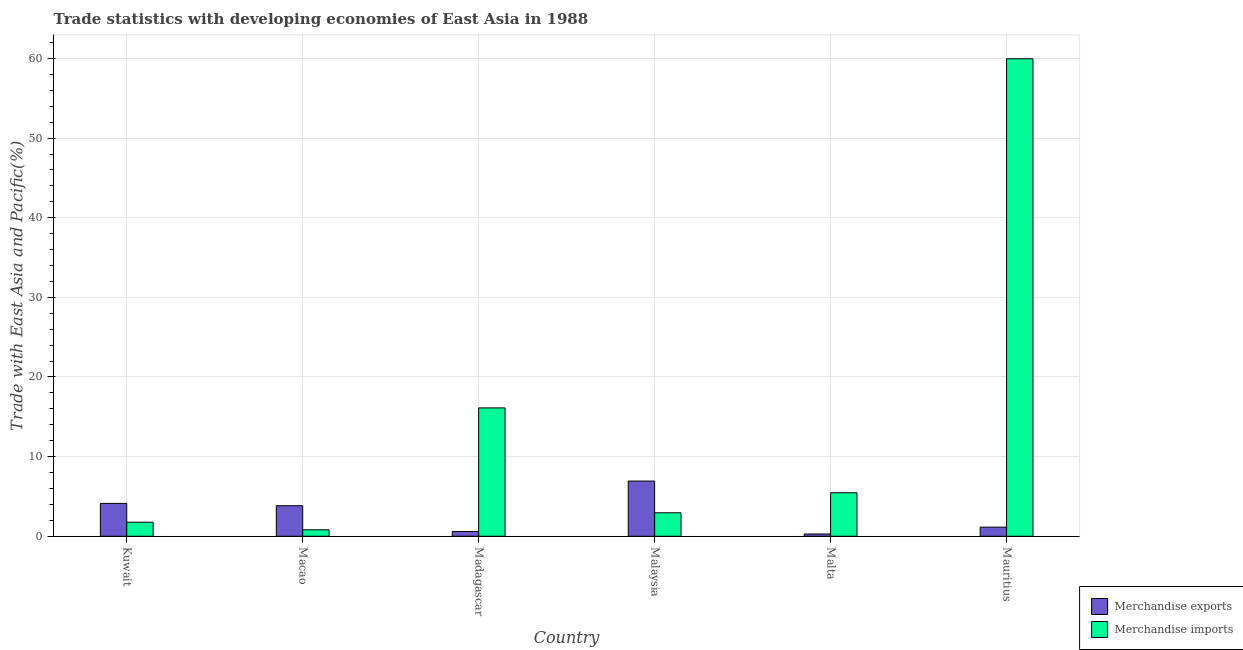Are the number of bars per tick equal to the number of legend labels?
Ensure brevity in your answer.  Yes. How many bars are there on the 5th tick from the left?
Give a very brief answer. 2. How many bars are there on the 6th tick from the right?
Keep it short and to the point. 2. What is the label of the 2nd group of bars from the left?
Ensure brevity in your answer.  Macao. In how many cases, is the number of bars for a given country not equal to the number of legend labels?
Your answer should be compact. 0. What is the merchandise imports in Madagascar?
Your answer should be very brief. 16.12. Across all countries, what is the maximum merchandise imports?
Your response must be concise. 59.97. Across all countries, what is the minimum merchandise imports?
Offer a terse response. 0.81. In which country was the merchandise exports maximum?
Offer a very short reply. Malaysia. In which country was the merchandise imports minimum?
Keep it short and to the point. Macao. What is the total merchandise imports in the graph?
Give a very brief answer. 87.07. What is the difference between the merchandise imports in Kuwait and that in Mauritius?
Your answer should be compact. -58.2. What is the difference between the merchandise imports in Malaysia and the merchandise exports in Malta?
Your answer should be very brief. 2.66. What is the average merchandise exports per country?
Make the answer very short. 2.82. What is the difference between the merchandise exports and merchandise imports in Kuwait?
Ensure brevity in your answer.  2.36. In how many countries, is the merchandise imports greater than 38 %?
Make the answer very short. 1. What is the ratio of the merchandise exports in Kuwait to that in Madagascar?
Provide a succinct answer. 6.95. What is the difference between the highest and the second highest merchandise exports?
Offer a terse response. 2.8. What is the difference between the highest and the lowest merchandise imports?
Provide a succinct answer. 59.16. In how many countries, is the merchandise exports greater than the average merchandise exports taken over all countries?
Keep it short and to the point. 3. What does the 1st bar from the left in Kuwait represents?
Your answer should be compact. Merchandise exports. Are all the bars in the graph horizontal?
Provide a succinct answer. No. How many countries are there in the graph?
Keep it short and to the point. 6. Does the graph contain any zero values?
Offer a terse response. No. What is the title of the graph?
Make the answer very short. Trade statistics with developing economies of East Asia in 1988. Does "Not attending school" appear as one of the legend labels in the graph?
Your response must be concise. No. What is the label or title of the X-axis?
Offer a terse response. Country. What is the label or title of the Y-axis?
Your answer should be very brief. Trade with East Asia and Pacific(%). What is the Trade with East Asia and Pacific(%) in Merchandise exports in Kuwait?
Make the answer very short. 4.13. What is the Trade with East Asia and Pacific(%) in Merchandise imports in Kuwait?
Keep it short and to the point. 1.76. What is the Trade with East Asia and Pacific(%) in Merchandise exports in Macao?
Offer a terse response. 3.84. What is the Trade with East Asia and Pacific(%) of Merchandise imports in Macao?
Offer a terse response. 0.81. What is the Trade with East Asia and Pacific(%) of Merchandise exports in Madagascar?
Keep it short and to the point. 0.59. What is the Trade with East Asia and Pacific(%) of Merchandise imports in Madagascar?
Your answer should be very brief. 16.12. What is the Trade with East Asia and Pacific(%) of Merchandise exports in Malaysia?
Offer a terse response. 6.93. What is the Trade with East Asia and Pacific(%) of Merchandise imports in Malaysia?
Your response must be concise. 2.95. What is the Trade with East Asia and Pacific(%) in Merchandise exports in Malta?
Offer a very short reply. 0.28. What is the Trade with East Asia and Pacific(%) in Merchandise imports in Malta?
Offer a very short reply. 5.46. What is the Trade with East Asia and Pacific(%) of Merchandise exports in Mauritius?
Keep it short and to the point. 1.15. What is the Trade with East Asia and Pacific(%) in Merchandise imports in Mauritius?
Give a very brief answer. 59.97. Across all countries, what is the maximum Trade with East Asia and Pacific(%) in Merchandise exports?
Provide a succinct answer. 6.93. Across all countries, what is the maximum Trade with East Asia and Pacific(%) of Merchandise imports?
Your answer should be very brief. 59.97. Across all countries, what is the minimum Trade with East Asia and Pacific(%) of Merchandise exports?
Offer a very short reply. 0.28. Across all countries, what is the minimum Trade with East Asia and Pacific(%) in Merchandise imports?
Provide a short and direct response. 0.81. What is the total Trade with East Asia and Pacific(%) of Merchandise exports in the graph?
Offer a very short reply. 16.91. What is the total Trade with East Asia and Pacific(%) in Merchandise imports in the graph?
Your response must be concise. 87.07. What is the difference between the Trade with East Asia and Pacific(%) in Merchandise exports in Kuwait and that in Macao?
Offer a terse response. 0.29. What is the difference between the Trade with East Asia and Pacific(%) in Merchandise imports in Kuwait and that in Macao?
Offer a very short reply. 0.95. What is the difference between the Trade with East Asia and Pacific(%) of Merchandise exports in Kuwait and that in Madagascar?
Offer a terse response. 3.53. What is the difference between the Trade with East Asia and Pacific(%) in Merchandise imports in Kuwait and that in Madagascar?
Provide a short and direct response. -14.36. What is the difference between the Trade with East Asia and Pacific(%) of Merchandise exports in Kuwait and that in Malaysia?
Offer a very short reply. -2.8. What is the difference between the Trade with East Asia and Pacific(%) of Merchandise imports in Kuwait and that in Malaysia?
Ensure brevity in your answer.  -1.18. What is the difference between the Trade with East Asia and Pacific(%) in Merchandise exports in Kuwait and that in Malta?
Your answer should be compact. 3.84. What is the difference between the Trade with East Asia and Pacific(%) in Merchandise imports in Kuwait and that in Malta?
Your answer should be compact. -3.7. What is the difference between the Trade with East Asia and Pacific(%) of Merchandise exports in Kuwait and that in Mauritius?
Your response must be concise. 2.98. What is the difference between the Trade with East Asia and Pacific(%) in Merchandise imports in Kuwait and that in Mauritius?
Ensure brevity in your answer.  -58.2. What is the difference between the Trade with East Asia and Pacific(%) of Merchandise exports in Macao and that in Madagascar?
Offer a very short reply. 3.24. What is the difference between the Trade with East Asia and Pacific(%) in Merchandise imports in Macao and that in Madagascar?
Your answer should be compact. -15.31. What is the difference between the Trade with East Asia and Pacific(%) in Merchandise exports in Macao and that in Malaysia?
Offer a terse response. -3.09. What is the difference between the Trade with East Asia and Pacific(%) of Merchandise imports in Macao and that in Malaysia?
Your response must be concise. -2.14. What is the difference between the Trade with East Asia and Pacific(%) in Merchandise exports in Macao and that in Malta?
Offer a terse response. 3.55. What is the difference between the Trade with East Asia and Pacific(%) in Merchandise imports in Macao and that in Malta?
Your answer should be compact. -4.65. What is the difference between the Trade with East Asia and Pacific(%) of Merchandise exports in Macao and that in Mauritius?
Provide a succinct answer. 2.69. What is the difference between the Trade with East Asia and Pacific(%) in Merchandise imports in Macao and that in Mauritius?
Provide a succinct answer. -59.16. What is the difference between the Trade with East Asia and Pacific(%) in Merchandise exports in Madagascar and that in Malaysia?
Give a very brief answer. -6.34. What is the difference between the Trade with East Asia and Pacific(%) in Merchandise imports in Madagascar and that in Malaysia?
Make the answer very short. 13.17. What is the difference between the Trade with East Asia and Pacific(%) of Merchandise exports in Madagascar and that in Malta?
Ensure brevity in your answer.  0.31. What is the difference between the Trade with East Asia and Pacific(%) in Merchandise imports in Madagascar and that in Malta?
Provide a short and direct response. 10.66. What is the difference between the Trade with East Asia and Pacific(%) of Merchandise exports in Madagascar and that in Mauritius?
Provide a short and direct response. -0.55. What is the difference between the Trade with East Asia and Pacific(%) in Merchandise imports in Madagascar and that in Mauritius?
Provide a short and direct response. -43.85. What is the difference between the Trade with East Asia and Pacific(%) in Merchandise exports in Malaysia and that in Malta?
Provide a short and direct response. 6.65. What is the difference between the Trade with East Asia and Pacific(%) in Merchandise imports in Malaysia and that in Malta?
Provide a short and direct response. -2.52. What is the difference between the Trade with East Asia and Pacific(%) in Merchandise exports in Malaysia and that in Mauritius?
Offer a very short reply. 5.78. What is the difference between the Trade with East Asia and Pacific(%) of Merchandise imports in Malaysia and that in Mauritius?
Keep it short and to the point. -57.02. What is the difference between the Trade with East Asia and Pacific(%) in Merchandise exports in Malta and that in Mauritius?
Your answer should be very brief. -0.86. What is the difference between the Trade with East Asia and Pacific(%) of Merchandise imports in Malta and that in Mauritius?
Your response must be concise. -54.5. What is the difference between the Trade with East Asia and Pacific(%) of Merchandise exports in Kuwait and the Trade with East Asia and Pacific(%) of Merchandise imports in Macao?
Your response must be concise. 3.32. What is the difference between the Trade with East Asia and Pacific(%) in Merchandise exports in Kuwait and the Trade with East Asia and Pacific(%) in Merchandise imports in Madagascar?
Provide a short and direct response. -11.99. What is the difference between the Trade with East Asia and Pacific(%) of Merchandise exports in Kuwait and the Trade with East Asia and Pacific(%) of Merchandise imports in Malaysia?
Your response must be concise. 1.18. What is the difference between the Trade with East Asia and Pacific(%) of Merchandise exports in Kuwait and the Trade with East Asia and Pacific(%) of Merchandise imports in Malta?
Your response must be concise. -1.34. What is the difference between the Trade with East Asia and Pacific(%) in Merchandise exports in Kuwait and the Trade with East Asia and Pacific(%) in Merchandise imports in Mauritius?
Offer a very short reply. -55.84. What is the difference between the Trade with East Asia and Pacific(%) in Merchandise exports in Macao and the Trade with East Asia and Pacific(%) in Merchandise imports in Madagascar?
Offer a terse response. -12.28. What is the difference between the Trade with East Asia and Pacific(%) in Merchandise exports in Macao and the Trade with East Asia and Pacific(%) in Merchandise imports in Malaysia?
Ensure brevity in your answer.  0.89. What is the difference between the Trade with East Asia and Pacific(%) of Merchandise exports in Macao and the Trade with East Asia and Pacific(%) of Merchandise imports in Malta?
Your answer should be compact. -1.63. What is the difference between the Trade with East Asia and Pacific(%) in Merchandise exports in Macao and the Trade with East Asia and Pacific(%) in Merchandise imports in Mauritius?
Provide a succinct answer. -56.13. What is the difference between the Trade with East Asia and Pacific(%) of Merchandise exports in Madagascar and the Trade with East Asia and Pacific(%) of Merchandise imports in Malaysia?
Your answer should be very brief. -2.36. What is the difference between the Trade with East Asia and Pacific(%) of Merchandise exports in Madagascar and the Trade with East Asia and Pacific(%) of Merchandise imports in Malta?
Offer a very short reply. -4.87. What is the difference between the Trade with East Asia and Pacific(%) in Merchandise exports in Madagascar and the Trade with East Asia and Pacific(%) in Merchandise imports in Mauritius?
Keep it short and to the point. -59.37. What is the difference between the Trade with East Asia and Pacific(%) of Merchandise exports in Malaysia and the Trade with East Asia and Pacific(%) of Merchandise imports in Malta?
Your response must be concise. 1.47. What is the difference between the Trade with East Asia and Pacific(%) of Merchandise exports in Malaysia and the Trade with East Asia and Pacific(%) of Merchandise imports in Mauritius?
Your answer should be very brief. -53.04. What is the difference between the Trade with East Asia and Pacific(%) in Merchandise exports in Malta and the Trade with East Asia and Pacific(%) in Merchandise imports in Mauritius?
Give a very brief answer. -59.68. What is the average Trade with East Asia and Pacific(%) in Merchandise exports per country?
Keep it short and to the point. 2.82. What is the average Trade with East Asia and Pacific(%) of Merchandise imports per country?
Ensure brevity in your answer.  14.51. What is the difference between the Trade with East Asia and Pacific(%) of Merchandise exports and Trade with East Asia and Pacific(%) of Merchandise imports in Kuwait?
Give a very brief answer. 2.36. What is the difference between the Trade with East Asia and Pacific(%) in Merchandise exports and Trade with East Asia and Pacific(%) in Merchandise imports in Macao?
Make the answer very short. 3.03. What is the difference between the Trade with East Asia and Pacific(%) in Merchandise exports and Trade with East Asia and Pacific(%) in Merchandise imports in Madagascar?
Ensure brevity in your answer.  -15.53. What is the difference between the Trade with East Asia and Pacific(%) in Merchandise exports and Trade with East Asia and Pacific(%) in Merchandise imports in Malaysia?
Provide a short and direct response. 3.98. What is the difference between the Trade with East Asia and Pacific(%) of Merchandise exports and Trade with East Asia and Pacific(%) of Merchandise imports in Malta?
Your response must be concise. -5.18. What is the difference between the Trade with East Asia and Pacific(%) in Merchandise exports and Trade with East Asia and Pacific(%) in Merchandise imports in Mauritius?
Ensure brevity in your answer.  -58.82. What is the ratio of the Trade with East Asia and Pacific(%) in Merchandise exports in Kuwait to that in Macao?
Keep it short and to the point. 1.08. What is the ratio of the Trade with East Asia and Pacific(%) of Merchandise imports in Kuwait to that in Macao?
Provide a short and direct response. 2.18. What is the ratio of the Trade with East Asia and Pacific(%) of Merchandise exports in Kuwait to that in Madagascar?
Ensure brevity in your answer.  6.95. What is the ratio of the Trade with East Asia and Pacific(%) in Merchandise imports in Kuwait to that in Madagascar?
Make the answer very short. 0.11. What is the ratio of the Trade with East Asia and Pacific(%) of Merchandise exports in Kuwait to that in Malaysia?
Provide a succinct answer. 0.6. What is the ratio of the Trade with East Asia and Pacific(%) in Merchandise imports in Kuwait to that in Malaysia?
Provide a succinct answer. 0.6. What is the ratio of the Trade with East Asia and Pacific(%) in Merchandise exports in Kuwait to that in Malta?
Make the answer very short. 14.54. What is the ratio of the Trade with East Asia and Pacific(%) of Merchandise imports in Kuwait to that in Malta?
Keep it short and to the point. 0.32. What is the ratio of the Trade with East Asia and Pacific(%) in Merchandise exports in Kuwait to that in Mauritius?
Provide a succinct answer. 3.6. What is the ratio of the Trade with East Asia and Pacific(%) in Merchandise imports in Kuwait to that in Mauritius?
Your answer should be very brief. 0.03. What is the ratio of the Trade with East Asia and Pacific(%) in Merchandise exports in Macao to that in Madagascar?
Your answer should be very brief. 6.46. What is the ratio of the Trade with East Asia and Pacific(%) of Merchandise imports in Macao to that in Madagascar?
Offer a terse response. 0.05. What is the ratio of the Trade with East Asia and Pacific(%) in Merchandise exports in Macao to that in Malaysia?
Your response must be concise. 0.55. What is the ratio of the Trade with East Asia and Pacific(%) in Merchandise imports in Macao to that in Malaysia?
Your answer should be very brief. 0.27. What is the ratio of the Trade with East Asia and Pacific(%) in Merchandise exports in Macao to that in Malta?
Offer a terse response. 13.52. What is the ratio of the Trade with East Asia and Pacific(%) in Merchandise imports in Macao to that in Malta?
Offer a terse response. 0.15. What is the ratio of the Trade with East Asia and Pacific(%) in Merchandise exports in Macao to that in Mauritius?
Offer a very short reply. 3.35. What is the ratio of the Trade with East Asia and Pacific(%) of Merchandise imports in Macao to that in Mauritius?
Keep it short and to the point. 0.01. What is the ratio of the Trade with East Asia and Pacific(%) of Merchandise exports in Madagascar to that in Malaysia?
Provide a succinct answer. 0.09. What is the ratio of the Trade with East Asia and Pacific(%) of Merchandise imports in Madagascar to that in Malaysia?
Keep it short and to the point. 5.47. What is the ratio of the Trade with East Asia and Pacific(%) in Merchandise exports in Madagascar to that in Malta?
Provide a succinct answer. 2.09. What is the ratio of the Trade with East Asia and Pacific(%) of Merchandise imports in Madagascar to that in Malta?
Provide a short and direct response. 2.95. What is the ratio of the Trade with East Asia and Pacific(%) of Merchandise exports in Madagascar to that in Mauritius?
Your answer should be compact. 0.52. What is the ratio of the Trade with East Asia and Pacific(%) of Merchandise imports in Madagascar to that in Mauritius?
Offer a terse response. 0.27. What is the ratio of the Trade with East Asia and Pacific(%) in Merchandise exports in Malaysia to that in Malta?
Provide a short and direct response. 24.42. What is the ratio of the Trade with East Asia and Pacific(%) in Merchandise imports in Malaysia to that in Malta?
Ensure brevity in your answer.  0.54. What is the ratio of the Trade with East Asia and Pacific(%) of Merchandise exports in Malaysia to that in Mauritius?
Your response must be concise. 6.05. What is the ratio of the Trade with East Asia and Pacific(%) of Merchandise imports in Malaysia to that in Mauritius?
Give a very brief answer. 0.05. What is the ratio of the Trade with East Asia and Pacific(%) of Merchandise exports in Malta to that in Mauritius?
Offer a terse response. 0.25. What is the ratio of the Trade with East Asia and Pacific(%) of Merchandise imports in Malta to that in Mauritius?
Offer a terse response. 0.09. What is the difference between the highest and the second highest Trade with East Asia and Pacific(%) of Merchandise exports?
Give a very brief answer. 2.8. What is the difference between the highest and the second highest Trade with East Asia and Pacific(%) of Merchandise imports?
Your response must be concise. 43.85. What is the difference between the highest and the lowest Trade with East Asia and Pacific(%) of Merchandise exports?
Make the answer very short. 6.65. What is the difference between the highest and the lowest Trade with East Asia and Pacific(%) of Merchandise imports?
Ensure brevity in your answer.  59.16. 